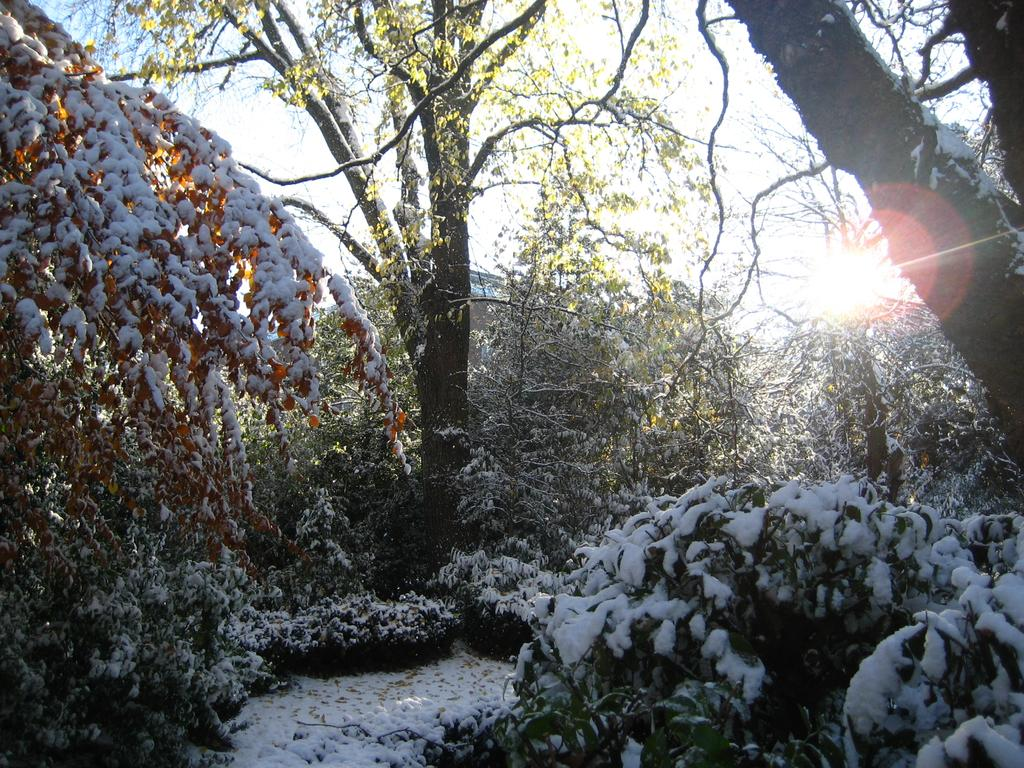What type of weather is depicted in the image? The image shows snow on the ground and plants, indicating cold weather. What else is covered in snow in the image? There are trees with snow in the background of the image. Can you see any natural light in the image? Yes, sunlight is visible in the image. What type of honey can be seen dripping from the trees in the image? There is no honey present in the image; it features snow-covered trees. Can you describe the cheese that is being bitten by the animal in the image? There is no animal or cheese present in the image. 